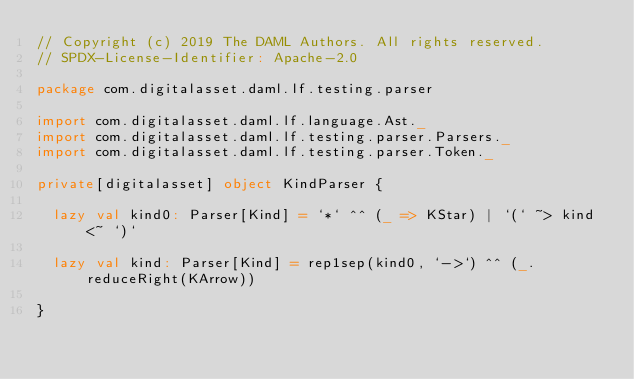<code> <loc_0><loc_0><loc_500><loc_500><_Scala_>// Copyright (c) 2019 The DAML Authors. All rights reserved.
// SPDX-License-Identifier: Apache-2.0

package com.digitalasset.daml.lf.testing.parser

import com.digitalasset.daml.lf.language.Ast._
import com.digitalasset.daml.lf.testing.parser.Parsers._
import com.digitalasset.daml.lf.testing.parser.Token._

private[digitalasset] object KindParser {

  lazy val kind0: Parser[Kind] = `*` ^^ (_ => KStar) | `(` ~> kind <~ `)`

  lazy val kind: Parser[Kind] = rep1sep(kind0, `->`) ^^ (_.reduceRight(KArrow))

}
</code> 